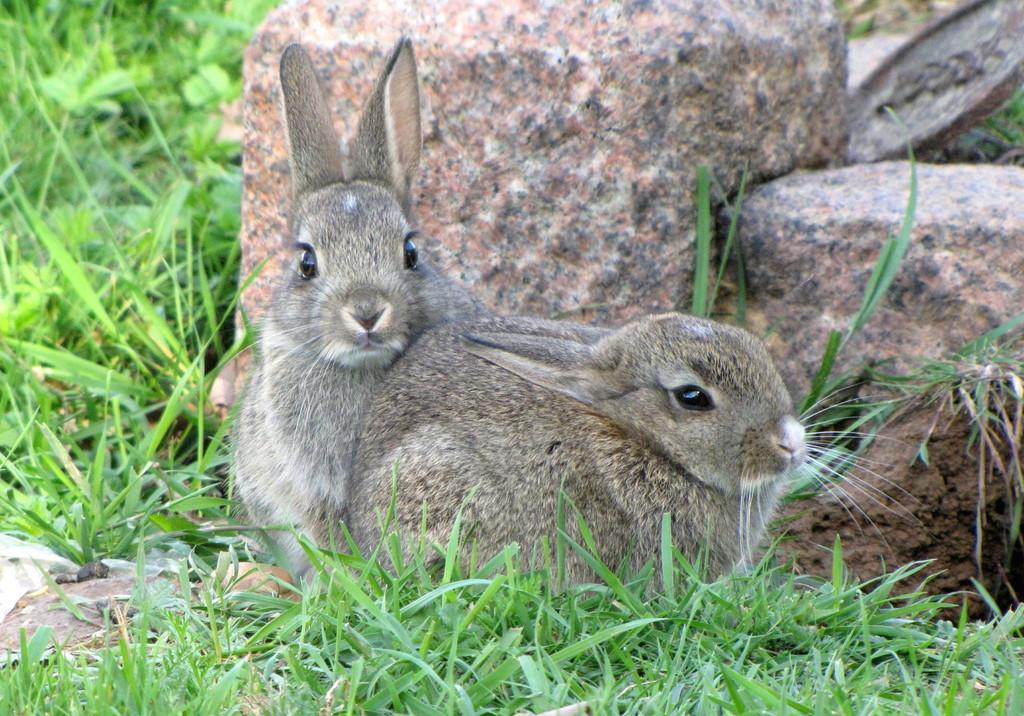How many rabbits are in the image? There are two rabbits in the image. What are the rabbits doing in the image? The rabbits are sitting on the ground. What type of vegetation is on the ground in the image? There is grass on the ground. What type of stones can be seen in the background of the image? There are granite stones on the ground in the background. What songs are the rabbits singing in the image? The rabbits are not singing in the image; they are sitting on the ground. What type of floor can be seen in the image? There is no floor visible in the image; it features rabbits sitting on the ground with grass and granite stones. 